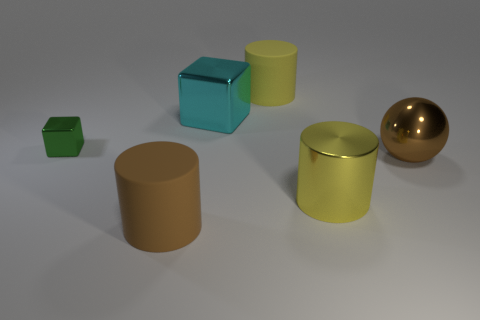What number of objects are either big blue matte spheres or cylinders in front of the shiny ball?
Keep it short and to the point. 2. Does the cylinder to the left of the cyan shiny thing have the same size as the brown thing that is on the right side of the yellow matte thing?
Provide a short and direct response. Yes. Is there a brown cylinder that has the same material as the large cyan cube?
Your answer should be compact. No. What shape is the tiny metal object?
Your answer should be compact. Cube. There is a big shiny object that is left of the yellow object that is behind the small green cube; what shape is it?
Your answer should be compact. Cube. What number of other things are the same shape as the big brown metallic thing?
Ensure brevity in your answer.  0. What is the size of the cylinder behind the big cyan cube that is to the right of the small green cube?
Ensure brevity in your answer.  Large. Is there a green shiny cube?
Keep it short and to the point. Yes. How many big matte objects are behind the brown object behind the brown cylinder?
Provide a short and direct response. 1. What is the shape of the big yellow thing in front of the small cube?
Offer a very short reply. Cylinder. 